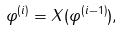<formula> <loc_0><loc_0><loc_500><loc_500>\varphi ^ { ( i ) } = X ( \varphi ^ { ( i - 1 ) } ) ,</formula> 